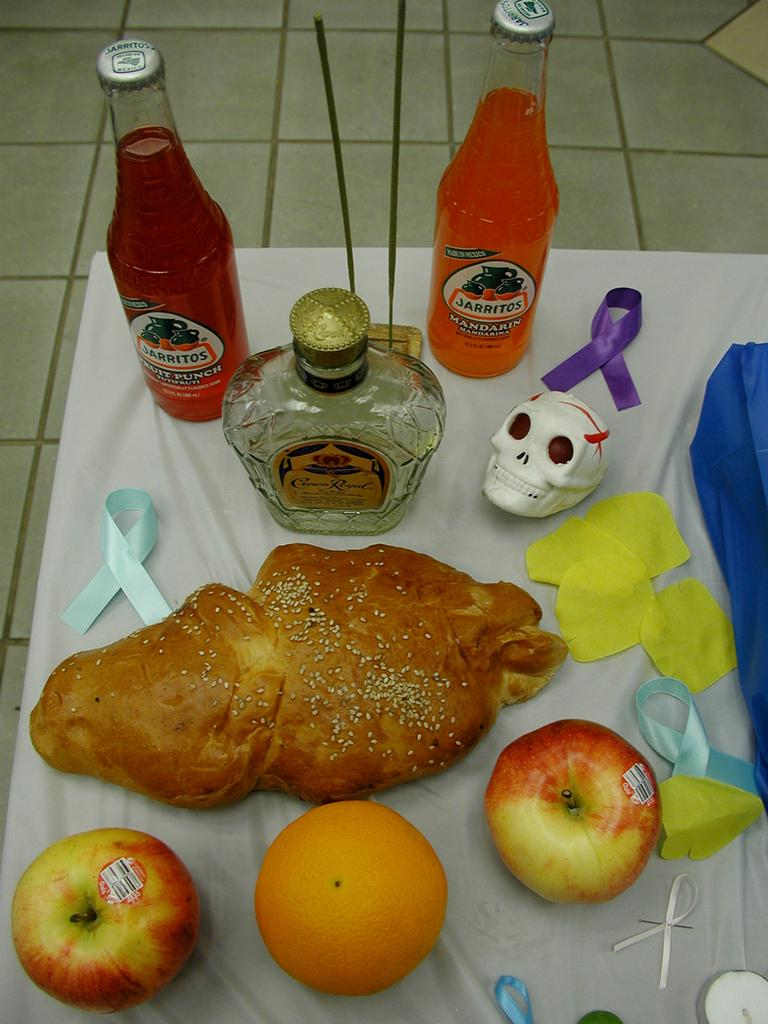What type of bread is in the image? There is a bun with sesame seeds in the image. What type of fruit can be seen in the image? There is an apple and an orange in the image. What decorative items are present in the image? There are ribbons in the image. What symbolic object is present in the image? There is a skull in the image. What type of containers are in the image? There are bottles in the image. On what surface are the objects placed? The objects are placed on a white cloth. How many pieces of popcorn are on the white cloth in the image? There is no popcorn present in the image. What level of difficulty is the image designed for? The image is not designed for a specific level of difficulty; it is a still image of various objects. 